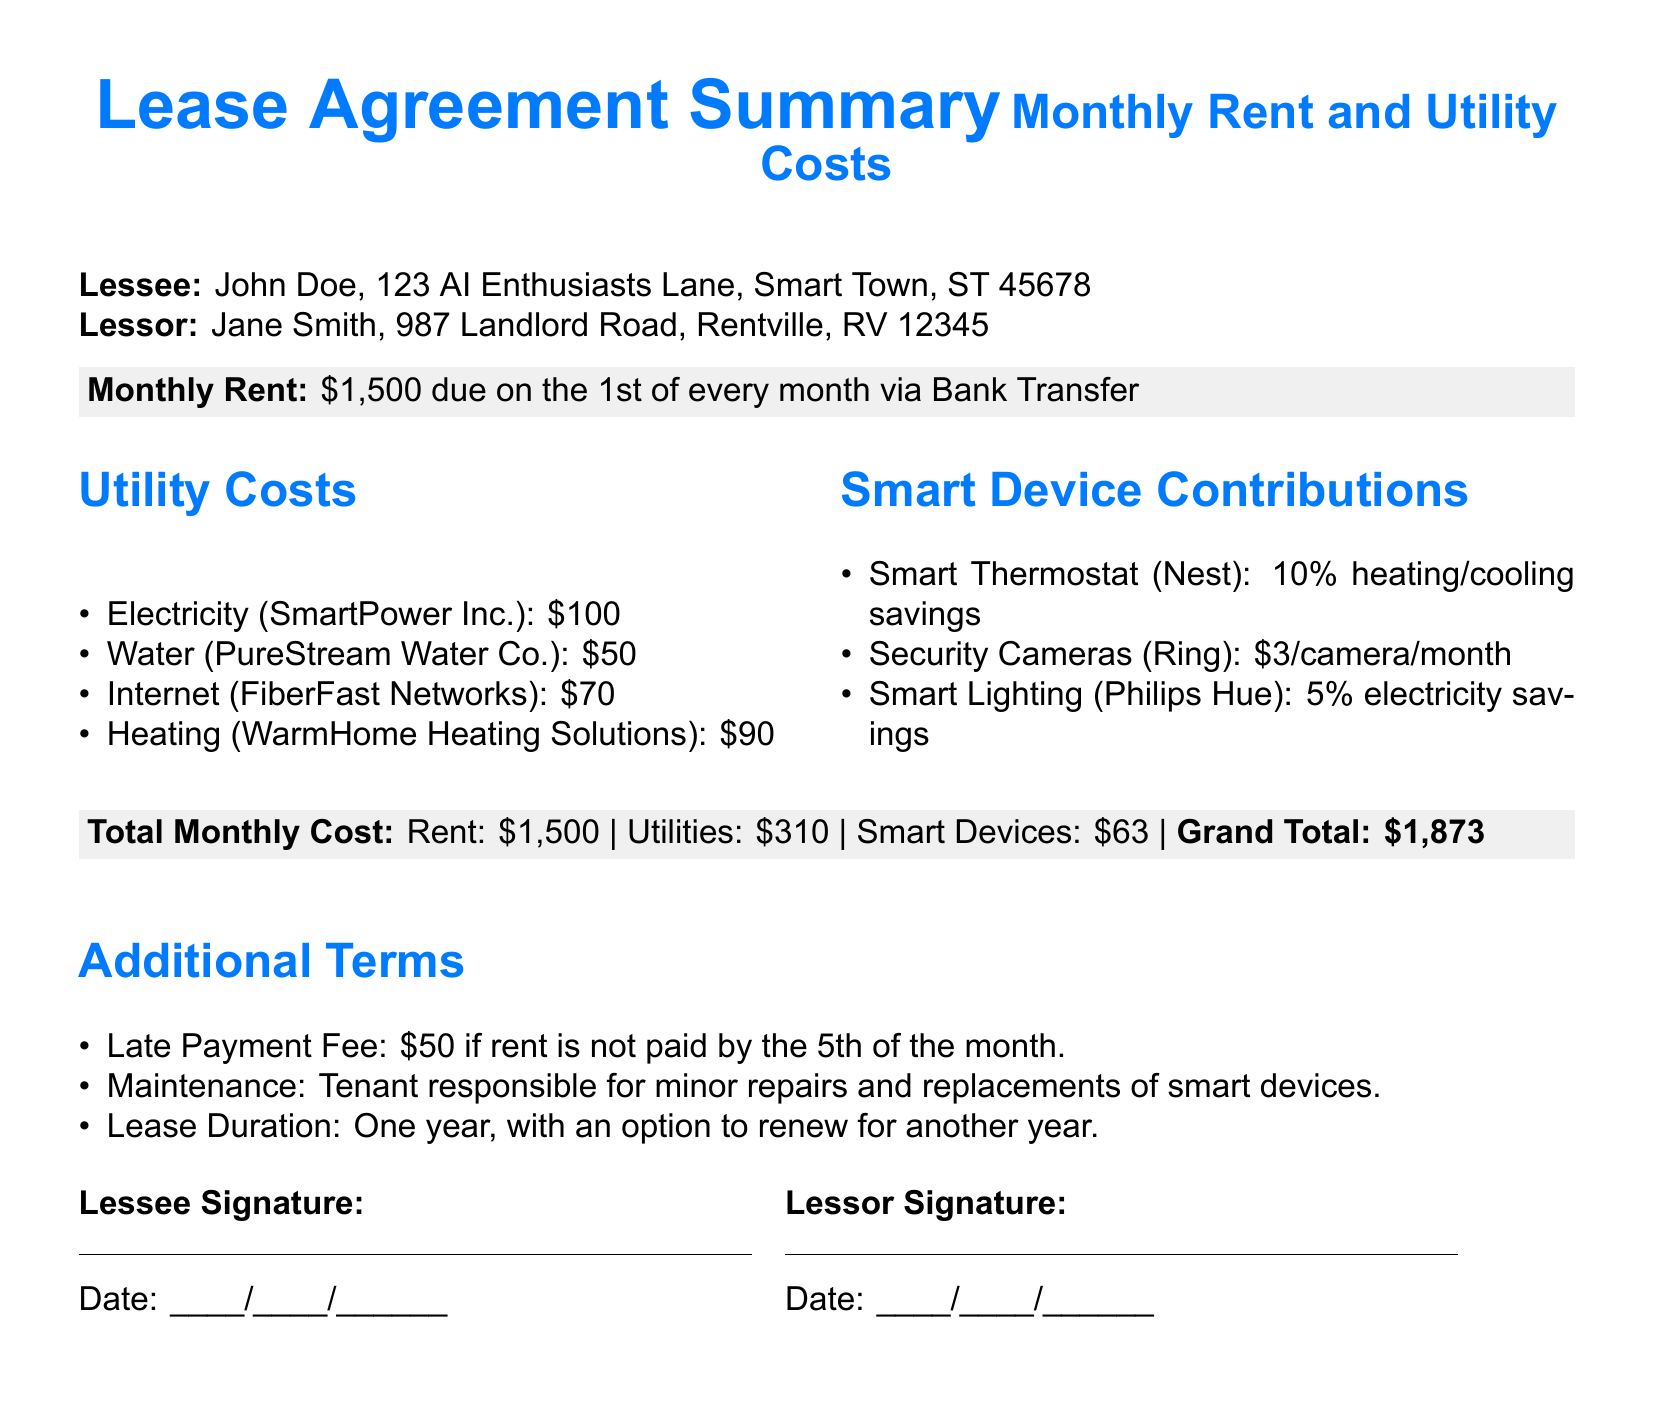What is the monthly rent? The monthly rent is explicitly stated in the document as $1,500.
Answer: $1,500 Who is the lessee? The lessee's name is provided in the document as John Doe.
Answer: John Doe What is the total utility cost? The utility costs are detailed and summed up in the document as $310.
Answer: $310 What is the contribution for security cameras? The document specifies that the cost is $3 per camera per month.
Answer: $3/camera/month What is the late payment fee? The document clearly mentions a late payment fee of $50 if rent is not paid by the 5th of the month.
Answer: $50 What is the percentage savings from the smart thermostat? The document states a savings of 10% on heating/cooling from the smart thermostat.
Answer: 10% What is the grand total monthly cost? The grand total monthly cost is summarized in the document as $1,873.
Answer: $1,873 What is the lease duration? The lease duration is stated to be one year, with an option to renew.
Answer: One year Who is responsible for minor repairs of smart devices? The document indicates the tenant is responsible for minor repairs and replacements of smart devices.
Answer: Tenant 